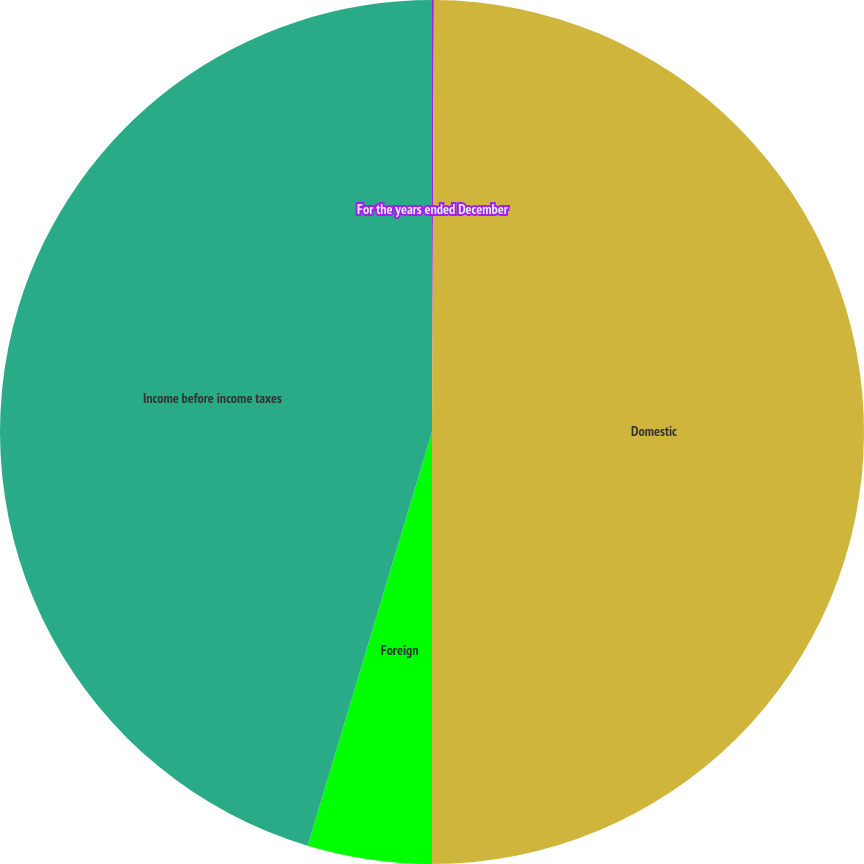Convert chart to OTSL. <chart><loc_0><loc_0><loc_500><loc_500><pie_chart><fcel>For the years ended December<fcel>Domestic<fcel>Foreign<fcel>Income before income taxes<nl><fcel>0.07%<fcel>49.93%<fcel>4.65%<fcel>45.35%<nl></chart> 